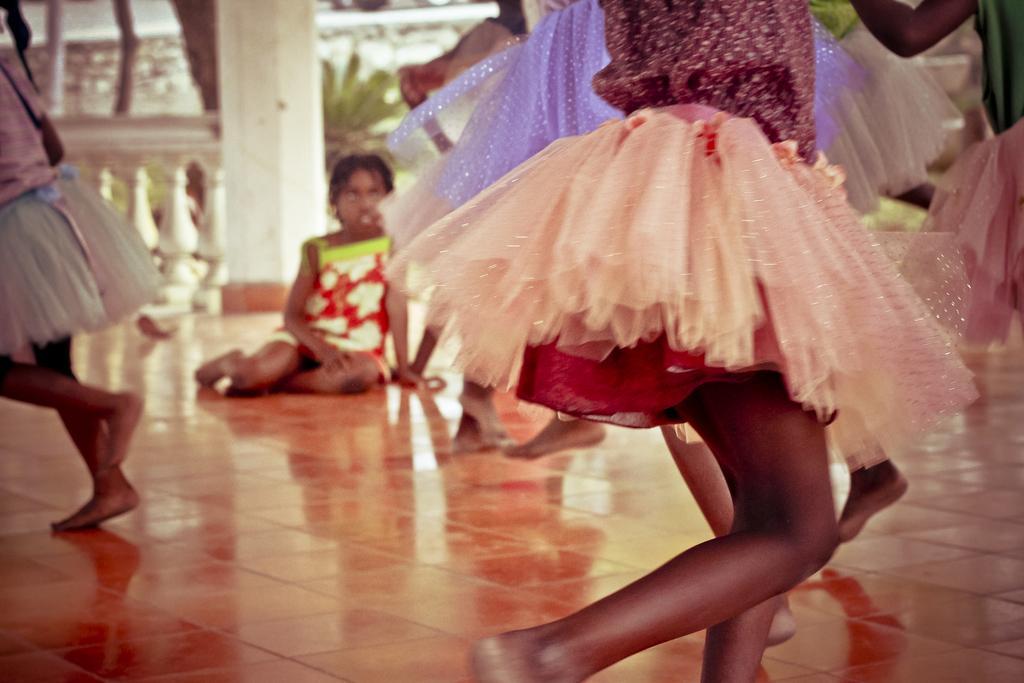In one or two sentences, can you explain what this image depicts? In this image I can see few people are dancing and wearing the different color dresses. One person is sitting on the floor. In the back I can see the railing, pillar, plant and the wall. 